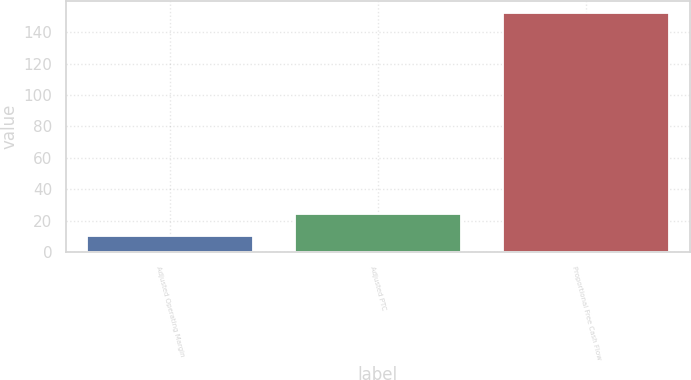<chart> <loc_0><loc_0><loc_500><loc_500><bar_chart><fcel>Adjusted Operating Margin<fcel>Adjusted PTC<fcel>Proportional Free Cash Flow<nl><fcel>10<fcel>24.2<fcel>152<nl></chart> 